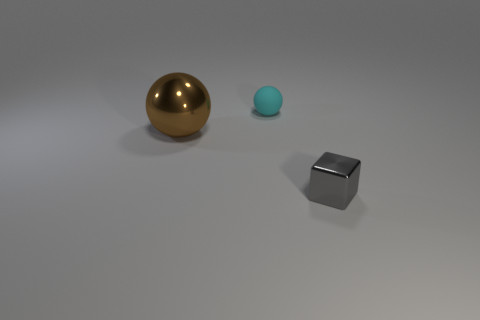What number of other things are the same shape as the gray thing?
Offer a terse response. 0. Are there any other things that have the same material as the cyan sphere?
Make the answer very short. No. There is a metallic thing left of the cyan matte sphere; is there a metallic object that is in front of it?
Your response must be concise. Yes. What number of objects are either things that are behind the big brown object or small things behind the tiny metal block?
Ensure brevity in your answer.  1. What is the color of the metal object left of the shiny object that is on the right side of the small thing left of the small block?
Give a very brief answer. Brown. What is the size of the metal thing that is to the right of the object behind the brown metal sphere?
Provide a short and direct response. Small. What is the thing that is to the right of the big brown metal sphere and in front of the cyan thing made of?
Provide a short and direct response. Metal. There is a cyan matte sphere; is it the same size as the shiny object that is in front of the big brown object?
Your answer should be compact. Yes. Are any gray shiny objects visible?
Your response must be concise. Yes. There is another object that is the same shape as the big shiny object; what is its material?
Provide a short and direct response. Rubber. 